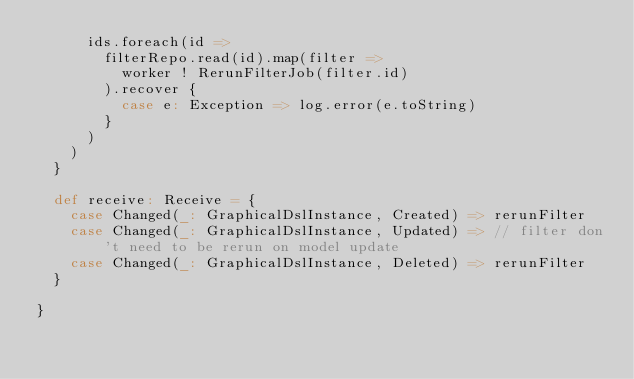Convert code to text. <code><loc_0><loc_0><loc_500><loc_500><_Scala_>      ids.foreach(id =>
        filterRepo.read(id).map(filter =>
          worker ! RerunFilterJob(filter.id)
        ).recover {
          case e: Exception => log.error(e.toString)
        }
      )
    )
  }

  def receive: Receive = {
    case Changed(_: GraphicalDslInstance, Created) => rerunFilter
    case Changed(_: GraphicalDslInstance, Updated) => // filter don't need to be rerun on model update
    case Changed(_: GraphicalDslInstance, Deleted) => rerunFilter
  }

}
</code> 